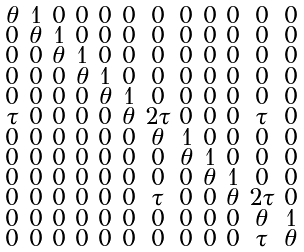<formula> <loc_0><loc_0><loc_500><loc_500>\begin{smallmatrix} \theta & 1 & 0 & 0 & 0 & 0 & 0 & 0 & 0 & 0 & 0 & 0 \\ 0 & \theta & 1 & 0 & 0 & 0 & 0 & 0 & 0 & 0 & 0 & 0 \\ 0 & 0 & \theta & 1 & 0 & 0 & 0 & 0 & 0 & 0 & 0 & 0 \\ 0 & 0 & 0 & \theta & 1 & 0 & 0 & 0 & 0 & 0 & 0 & 0 \\ 0 & 0 & 0 & 0 & \theta & 1 & 0 & 0 & 0 & 0 & 0 & 0 \\ \tau & 0 & 0 & 0 & 0 & \theta & 2 \tau & 0 & 0 & 0 & \tau & 0 \\ 0 & 0 & 0 & 0 & 0 & 0 & \theta & 1 & 0 & 0 & 0 & 0 \\ 0 & 0 & 0 & 0 & 0 & 0 & 0 & \theta & 1 & 0 & 0 & 0 \\ 0 & 0 & 0 & 0 & 0 & 0 & 0 & 0 & \theta & 1 & 0 & 0 \\ 0 & 0 & 0 & 0 & 0 & 0 & \tau & 0 & 0 & \theta & 2 \tau & 0 \\ 0 & 0 & 0 & 0 & 0 & 0 & 0 & 0 & 0 & 0 & \theta & 1 \\ 0 & 0 & 0 & 0 & 0 & 0 & 0 & 0 & 0 & 0 & \tau & \theta \\ \end{smallmatrix}</formula> 